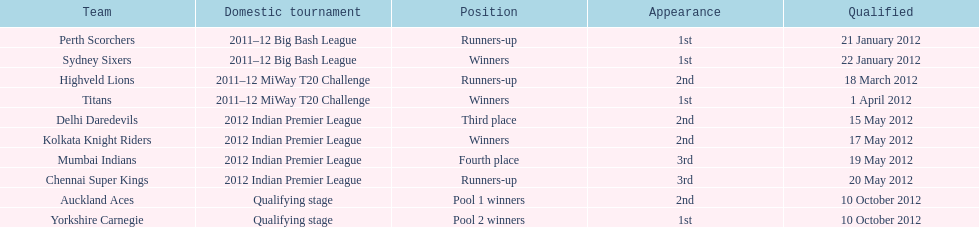Which team arrived following the titans in the miway t20 challenge? Highveld Lions. 